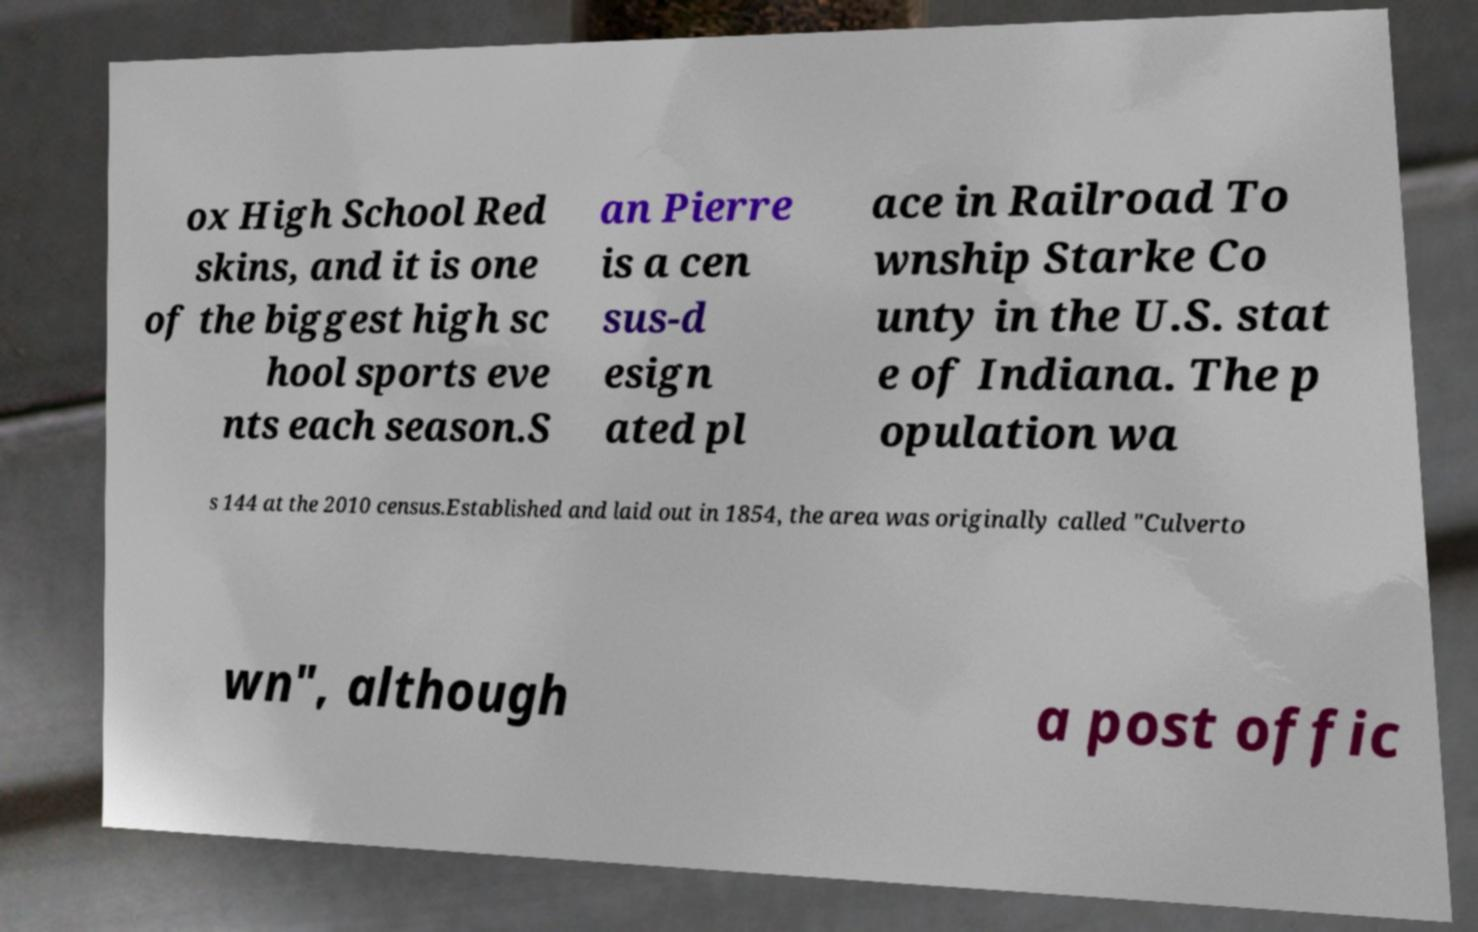There's text embedded in this image that I need extracted. Can you transcribe it verbatim? ox High School Red skins, and it is one of the biggest high sc hool sports eve nts each season.S an Pierre is a cen sus-d esign ated pl ace in Railroad To wnship Starke Co unty in the U.S. stat e of Indiana. The p opulation wa s 144 at the 2010 census.Established and laid out in 1854, the area was originally called "Culverto wn", although a post offic 